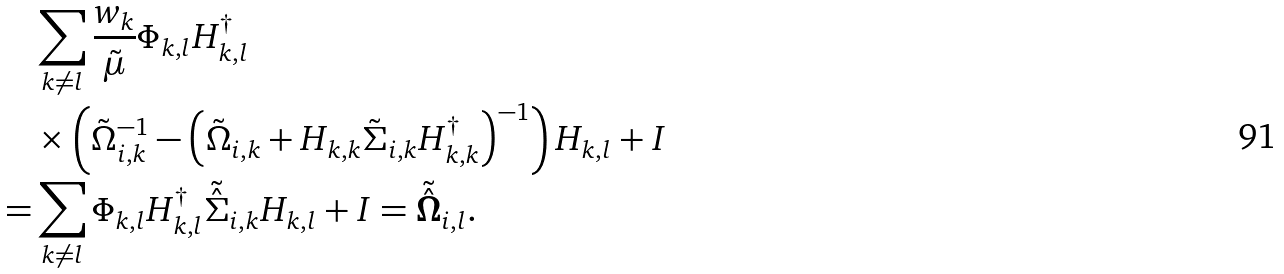Convert formula to latex. <formula><loc_0><loc_0><loc_500><loc_500>& \sum _ { k \neq l } \frac { w _ { k } } { \tilde { \mu } } \Phi _ { k , l } H _ { k , l } ^ { \dagger } \\ & \times \left ( \tilde { \Omega } _ { i , k } ^ { - 1 } - \left ( \tilde { \Omega } _ { i , k } + H _ { k , k } \tilde { \Sigma } _ { i , k } H _ { k , k } ^ { \dagger } \right ) ^ { - 1 } \right ) H _ { k , l } + I \\ = & \sum _ { k \neq l } \Phi _ { k , l } H _ { k , l } ^ { \dagger } \tilde { \hat { \Sigma } } _ { i , k } H _ { k , l } + I = \tilde { \hat { \mathbf { \Omega } } } _ { i , l } .</formula> 